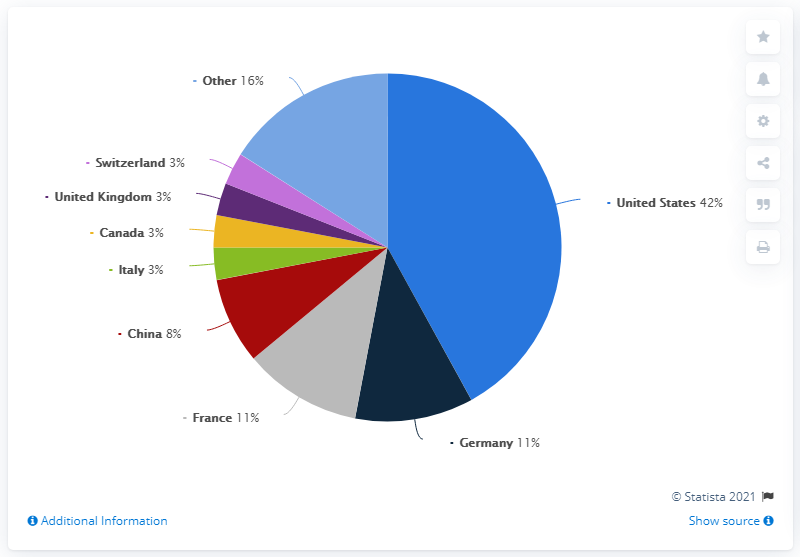Mention a couple of crucial points in this snapshot. According to a recent report, in 2019, China accounted for 8 percent of the global organic retail sales, making it the country with the highest share of the market. According to a recent report, the combined retail sales share of organic food in the United States and China in 2019 was approximately 50%. According to a recent study, the United States holds the largest retail sales share of organic food worldwide in 2019. 